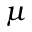<formula> <loc_0><loc_0><loc_500><loc_500>\mu</formula> 